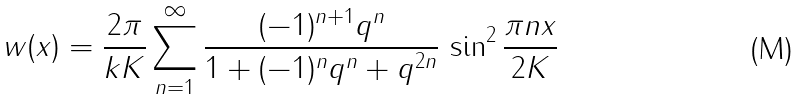<formula> <loc_0><loc_0><loc_500><loc_500>w ( x ) = \frac { 2 \pi } { k K } \sum _ { n = 1 } ^ { \infty } \frac { ( - 1 ) ^ { n + 1 } q ^ { n } } { 1 + ( - 1 ) ^ { n } q ^ { n } + q ^ { 2 n } } \, \sin ^ { 2 } \frac { \pi n x } { 2 K }</formula> 